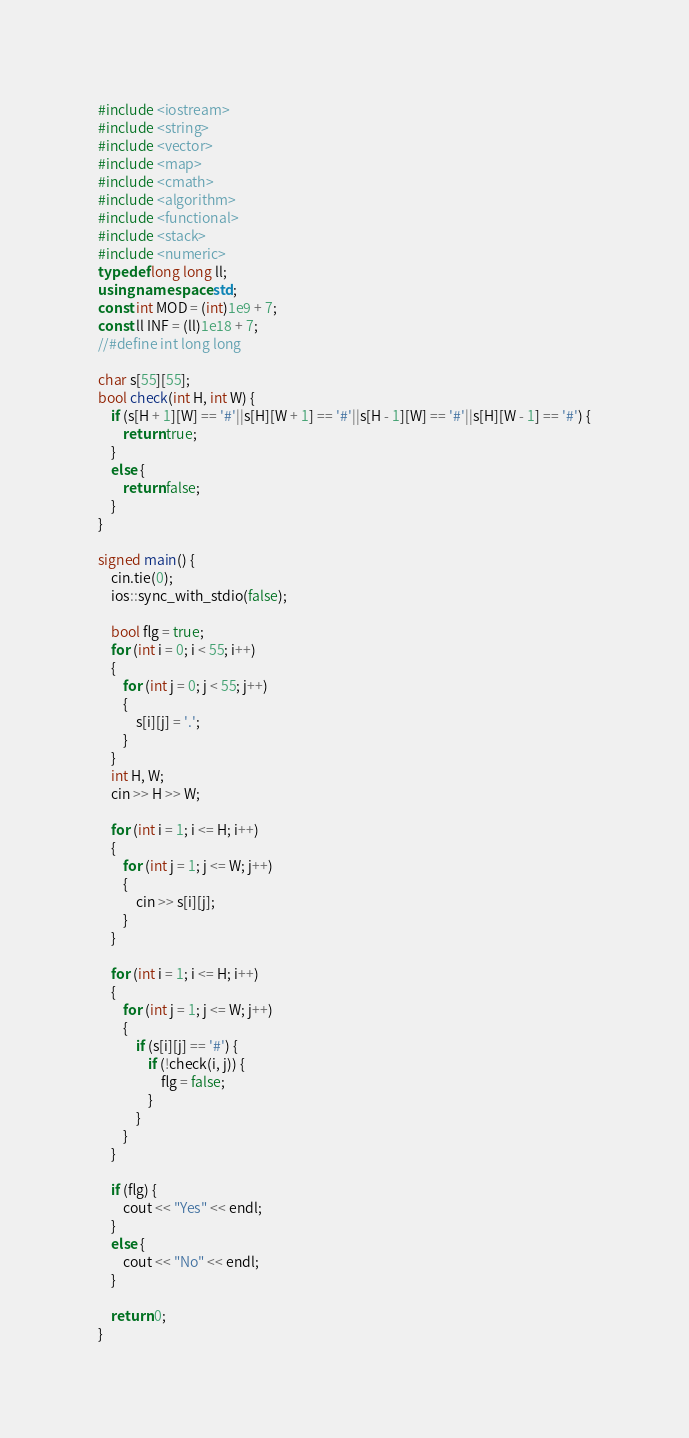Convert code to text. <code><loc_0><loc_0><loc_500><loc_500><_C++_>#include <iostream>
#include <string>
#include <vector>
#include <map>
#include <cmath>
#include <algorithm>
#include <functional>
#include <stack>
#include <numeric>
typedef long long ll;
using namespace std;
const int MOD = (int)1e9 + 7;
const ll INF = (ll)1e18 + 7;
//#define int long long

char s[55][55];
bool check(int H, int W) {
	if (s[H + 1][W] == '#'||s[H][W + 1] == '#'||s[H - 1][W] == '#'||s[H][W - 1] == '#') {
		return true;
	}
	else {
		return false;
	}
}

signed main() {
	cin.tie(0);
	ios::sync_with_stdio(false);

	bool flg = true;
	for (int i = 0; i < 55; i++)
	{
		for (int j = 0; j < 55; j++)
		{
			s[i][j] = '.';
		}
	}
	int H, W;
	cin >> H >> W;

	for (int i = 1; i <= H; i++)
	{
		for (int j = 1; j <= W; j++)
		{
			cin >> s[i][j];
		}
	}

	for (int i = 1; i <= H; i++)
	{
		for (int j = 1; j <= W; j++)
		{
			if (s[i][j] == '#') {
				if (!check(i, j)) {
					flg = false;
				}
			}
		}
	}

	if (flg) {
		cout << "Yes" << endl;
	}
	else {
		cout << "No" << endl;
	}

	return 0;
}
</code> 